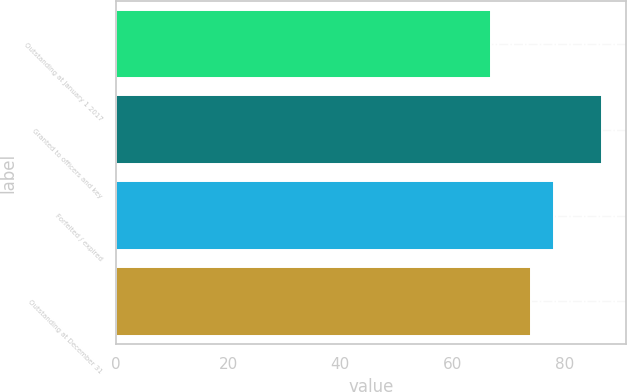Convert chart to OTSL. <chart><loc_0><loc_0><loc_500><loc_500><bar_chart><fcel>Outstanding at January 1 2017<fcel>Granted to officers and key<fcel>Forfeited / expired<fcel>Outstanding at December 31<nl><fcel>66.92<fcel>86.78<fcel>78.14<fcel>74.06<nl></chart> 